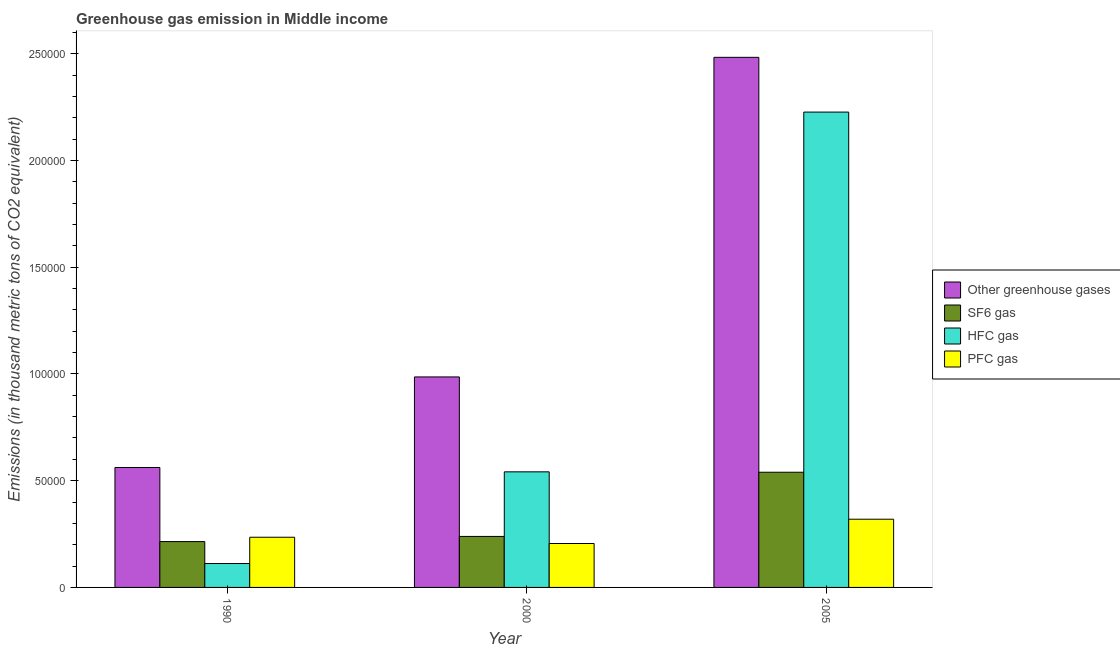How many different coloured bars are there?
Provide a short and direct response. 4. Are the number of bars per tick equal to the number of legend labels?
Your answer should be very brief. Yes. In how many cases, is the number of bars for a given year not equal to the number of legend labels?
Make the answer very short. 0. What is the emission of sf6 gas in 2005?
Ensure brevity in your answer.  5.39e+04. Across all years, what is the maximum emission of greenhouse gases?
Your answer should be very brief. 2.48e+05. Across all years, what is the minimum emission of hfc gas?
Keep it short and to the point. 1.12e+04. What is the total emission of hfc gas in the graph?
Provide a short and direct response. 2.88e+05. What is the difference between the emission of sf6 gas in 1990 and that in 2000?
Your answer should be compact. -2413.4. What is the difference between the emission of greenhouse gases in 1990 and the emission of hfc gas in 2000?
Your answer should be very brief. -4.24e+04. What is the average emission of greenhouse gases per year?
Give a very brief answer. 1.34e+05. What is the ratio of the emission of hfc gas in 1990 to that in 2005?
Your answer should be compact. 0.05. Is the difference between the emission of sf6 gas in 1990 and 2000 greater than the difference between the emission of hfc gas in 1990 and 2000?
Make the answer very short. No. What is the difference between the highest and the second highest emission of greenhouse gases?
Offer a very short reply. 1.50e+05. What is the difference between the highest and the lowest emission of sf6 gas?
Make the answer very short. 3.25e+04. Is it the case that in every year, the sum of the emission of pfc gas and emission of hfc gas is greater than the sum of emission of sf6 gas and emission of greenhouse gases?
Offer a terse response. No. What does the 3rd bar from the left in 2000 represents?
Your response must be concise. HFC gas. What does the 1st bar from the right in 2005 represents?
Your response must be concise. PFC gas. How many bars are there?
Your answer should be compact. 12. How many years are there in the graph?
Provide a succinct answer. 3. Does the graph contain any zero values?
Offer a terse response. No. Does the graph contain grids?
Provide a short and direct response. No. How many legend labels are there?
Make the answer very short. 4. What is the title of the graph?
Provide a short and direct response. Greenhouse gas emission in Middle income. Does "Custom duties" appear as one of the legend labels in the graph?
Your response must be concise. No. What is the label or title of the Y-axis?
Provide a succinct answer. Emissions (in thousand metric tons of CO2 equivalent). What is the Emissions (in thousand metric tons of CO2 equivalent) of Other greenhouse gases in 1990?
Provide a short and direct response. 5.62e+04. What is the Emissions (in thousand metric tons of CO2 equivalent) in SF6 gas in 1990?
Offer a terse response. 2.15e+04. What is the Emissions (in thousand metric tons of CO2 equivalent) of HFC gas in 1990?
Your answer should be very brief. 1.12e+04. What is the Emissions (in thousand metric tons of CO2 equivalent) of PFC gas in 1990?
Ensure brevity in your answer.  2.35e+04. What is the Emissions (in thousand metric tons of CO2 equivalent) in Other greenhouse gases in 2000?
Your answer should be very brief. 9.86e+04. What is the Emissions (in thousand metric tons of CO2 equivalent) of SF6 gas in 2000?
Provide a short and direct response. 2.39e+04. What is the Emissions (in thousand metric tons of CO2 equivalent) of HFC gas in 2000?
Make the answer very short. 5.41e+04. What is the Emissions (in thousand metric tons of CO2 equivalent) in PFC gas in 2000?
Your answer should be compact. 2.06e+04. What is the Emissions (in thousand metric tons of CO2 equivalent) of Other greenhouse gases in 2005?
Provide a short and direct response. 2.48e+05. What is the Emissions (in thousand metric tons of CO2 equivalent) in SF6 gas in 2005?
Ensure brevity in your answer.  5.39e+04. What is the Emissions (in thousand metric tons of CO2 equivalent) of HFC gas in 2005?
Offer a terse response. 2.23e+05. What is the Emissions (in thousand metric tons of CO2 equivalent) of PFC gas in 2005?
Give a very brief answer. 3.20e+04. Across all years, what is the maximum Emissions (in thousand metric tons of CO2 equivalent) in Other greenhouse gases?
Offer a terse response. 2.48e+05. Across all years, what is the maximum Emissions (in thousand metric tons of CO2 equivalent) of SF6 gas?
Provide a succinct answer. 5.39e+04. Across all years, what is the maximum Emissions (in thousand metric tons of CO2 equivalent) in HFC gas?
Your answer should be compact. 2.23e+05. Across all years, what is the maximum Emissions (in thousand metric tons of CO2 equivalent) in PFC gas?
Offer a terse response. 3.20e+04. Across all years, what is the minimum Emissions (in thousand metric tons of CO2 equivalent) of Other greenhouse gases?
Ensure brevity in your answer.  5.62e+04. Across all years, what is the minimum Emissions (in thousand metric tons of CO2 equivalent) in SF6 gas?
Provide a short and direct response. 2.15e+04. Across all years, what is the minimum Emissions (in thousand metric tons of CO2 equivalent) in HFC gas?
Ensure brevity in your answer.  1.12e+04. Across all years, what is the minimum Emissions (in thousand metric tons of CO2 equivalent) in PFC gas?
Make the answer very short. 2.06e+04. What is the total Emissions (in thousand metric tons of CO2 equivalent) in Other greenhouse gases in the graph?
Ensure brevity in your answer.  4.03e+05. What is the total Emissions (in thousand metric tons of CO2 equivalent) in SF6 gas in the graph?
Ensure brevity in your answer.  9.93e+04. What is the total Emissions (in thousand metric tons of CO2 equivalent) of HFC gas in the graph?
Offer a terse response. 2.88e+05. What is the total Emissions (in thousand metric tons of CO2 equivalent) in PFC gas in the graph?
Keep it short and to the point. 7.60e+04. What is the difference between the Emissions (in thousand metric tons of CO2 equivalent) in Other greenhouse gases in 1990 and that in 2000?
Offer a terse response. -4.24e+04. What is the difference between the Emissions (in thousand metric tons of CO2 equivalent) in SF6 gas in 1990 and that in 2000?
Provide a short and direct response. -2413.4. What is the difference between the Emissions (in thousand metric tons of CO2 equivalent) in HFC gas in 1990 and that in 2000?
Provide a short and direct response. -4.29e+04. What is the difference between the Emissions (in thousand metric tons of CO2 equivalent) of PFC gas in 1990 and that in 2000?
Your answer should be very brief. 2931.5. What is the difference between the Emissions (in thousand metric tons of CO2 equivalent) of Other greenhouse gases in 1990 and that in 2005?
Offer a terse response. -1.92e+05. What is the difference between the Emissions (in thousand metric tons of CO2 equivalent) in SF6 gas in 1990 and that in 2005?
Give a very brief answer. -3.25e+04. What is the difference between the Emissions (in thousand metric tons of CO2 equivalent) in HFC gas in 1990 and that in 2005?
Provide a succinct answer. -2.11e+05. What is the difference between the Emissions (in thousand metric tons of CO2 equivalent) of PFC gas in 1990 and that in 2005?
Offer a terse response. -8451.4. What is the difference between the Emissions (in thousand metric tons of CO2 equivalent) of Other greenhouse gases in 2000 and that in 2005?
Offer a terse response. -1.50e+05. What is the difference between the Emissions (in thousand metric tons of CO2 equivalent) of SF6 gas in 2000 and that in 2005?
Offer a terse response. -3.01e+04. What is the difference between the Emissions (in thousand metric tons of CO2 equivalent) in HFC gas in 2000 and that in 2005?
Your response must be concise. -1.68e+05. What is the difference between the Emissions (in thousand metric tons of CO2 equivalent) of PFC gas in 2000 and that in 2005?
Keep it short and to the point. -1.14e+04. What is the difference between the Emissions (in thousand metric tons of CO2 equivalent) in Other greenhouse gases in 1990 and the Emissions (in thousand metric tons of CO2 equivalent) in SF6 gas in 2000?
Provide a short and direct response. 3.23e+04. What is the difference between the Emissions (in thousand metric tons of CO2 equivalent) of Other greenhouse gases in 1990 and the Emissions (in thousand metric tons of CO2 equivalent) of HFC gas in 2000?
Give a very brief answer. 2035.7. What is the difference between the Emissions (in thousand metric tons of CO2 equivalent) in Other greenhouse gases in 1990 and the Emissions (in thousand metric tons of CO2 equivalent) in PFC gas in 2000?
Offer a terse response. 3.56e+04. What is the difference between the Emissions (in thousand metric tons of CO2 equivalent) of SF6 gas in 1990 and the Emissions (in thousand metric tons of CO2 equivalent) of HFC gas in 2000?
Your response must be concise. -3.27e+04. What is the difference between the Emissions (in thousand metric tons of CO2 equivalent) in SF6 gas in 1990 and the Emissions (in thousand metric tons of CO2 equivalent) in PFC gas in 2000?
Keep it short and to the point. 902.9. What is the difference between the Emissions (in thousand metric tons of CO2 equivalent) in HFC gas in 1990 and the Emissions (in thousand metric tons of CO2 equivalent) in PFC gas in 2000?
Ensure brevity in your answer.  -9371.2. What is the difference between the Emissions (in thousand metric tons of CO2 equivalent) of Other greenhouse gases in 1990 and the Emissions (in thousand metric tons of CO2 equivalent) of SF6 gas in 2005?
Offer a very short reply. 2227.28. What is the difference between the Emissions (in thousand metric tons of CO2 equivalent) of Other greenhouse gases in 1990 and the Emissions (in thousand metric tons of CO2 equivalent) of HFC gas in 2005?
Your answer should be very brief. -1.66e+05. What is the difference between the Emissions (in thousand metric tons of CO2 equivalent) in Other greenhouse gases in 1990 and the Emissions (in thousand metric tons of CO2 equivalent) in PFC gas in 2005?
Ensure brevity in your answer.  2.42e+04. What is the difference between the Emissions (in thousand metric tons of CO2 equivalent) of SF6 gas in 1990 and the Emissions (in thousand metric tons of CO2 equivalent) of HFC gas in 2005?
Your answer should be very brief. -2.01e+05. What is the difference between the Emissions (in thousand metric tons of CO2 equivalent) of SF6 gas in 1990 and the Emissions (in thousand metric tons of CO2 equivalent) of PFC gas in 2005?
Provide a short and direct response. -1.05e+04. What is the difference between the Emissions (in thousand metric tons of CO2 equivalent) of HFC gas in 1990 and the Emissions (in thousand metric tons of CO2 equivalent) of PFC gas in 2005?
Ensure brevity in your answer.  -2.08e+04. What is the difference between the Emissions (in thousand metric tons of CO2 equivalent) in Other greenhouse gases in 2000 and the Emissions (in thousand metric tons of CO2 equivalent) in SF6 gas in 2005?
Make the answer very short. 4.46e+04. What is the difference between the Emissions (in thousand metric tons of CO2 equivalent) of Other greenhouse gases in 2000 and the Emissions (in thousand metric tons of CO2 equivalent) of HFC gas in 2005?
Give a very brief answer. -1.24e+05. What is the difference between the Emissions (in thousand metric tons of CO2 equivalent) of Other greenhouse gases in 2000 and the Emissions (in thousand metric tons of CO2 equivalent) of PFC gas in 2005?
Your response must be concise. 6.66e+04. What is the difference between the Emissions (in thousand metric tons of CO2 equivalent) of SF6 gas in 2000 and the Emissions (in thousand metric tons of CO2 equivalent) of HFC gas in 2005?
Offer a very short reply. -1.99e+05. What is the difference between the Emissions (in thousand metric tons of CO2 equivalent) of SF6 gas in 2000 and the Emissions (in thousand metric tons of CO2 equivalent) of PFC gas in 2005?
Offer a terse response. -8066.6. What is the difference between the Emissions (in thousand metric tons of CO2 equivalent) of HFC gas in 2000 and the Emissions (in thousand metric tons of CO2 equivalent) of PFC gas in 2005?
Provide a succinct answer. 2.22e+04. What is the average Emissions (in thousand metric tons of CO2 equivalent) of Other greenhouse gases per year?
Offer a terse response. 1.34e+05. What is the average Emissions (in thousand metric tons of CO2 equivalent) in SF6 gas per year?
Your response must be concise. 3.31e+04. What is the average Emissions (in thousand metric tons of CO2 equivalent) of HFC gas per year?
Your response must be concise. 9.60e+04. What is the average Emissions (in thousand metric tons of CO2 equivalent) of PFC gas per year?
Your answer should be very brief. 2.53e+04. In the year 1990, what is the difference between the Emissions (in thousand metric tons of CO2 equivalent) in Other greenhouse gases and Emissions (in thousand metric tons of CO2 equivalent) in SF6 gas?
Make the answer very short. 3.47e+04. In the year 1990, what is the difference between the Emissions (in thousand metric tons of CO2 equivalent) in Other greenhouse gases and Emissions (in thousand metric tons of CO2 equivalent) in HFC gas?
Provide a succinct answer. 4.50e+04. In the year 1990, what is the difference between the Emissions (in thousand metric tons of CO2 equivalent) of Other greenhouse gases and Emissions (in thousand metric tons of CO2 equivalent) of PFC gas?
Provide a short and direct response. 3.27e+04. In the year 1990, what is the difference between the Emissions (in thousand metric tons of CO2 equivalent) of SF6 gas and Emissions (in thousand metric tons of CO2 equivalent) of HFC gas?
Offer a terse response. 1.03e+04. In the year 1990, what is the difference between the Emissions (in thousand metric tons of CO2 equivalent) in SF6 gas and Emissions (in thousand metric tons of CO2 equivalent) in PFC gas?
Your response must be concise. -2028.6. In the year 1990, what is the difference between the Emissions (in thousand metric tons of CO2 equivalent) in HFC gas and Emissions (in thousand metric tons of CO2 equivalent) in PFC gas?
Your response must be concise. -1.23e+04. In the year 2000, what is the difference between the Emissions (in thousand metric tons of CO2 equivalent) of Other greenhouse gases and Emissions (in thousand metric tons of CO2 equivalent) of SF6 gas?
Your answer should be compact. 7.47e+04. In the year 2000, what is the difference between the Emissions (in thousand metric tons of CO2 equivalent) of Other greenhouse gases and Emissions (in thousand metric tons of CO2 equivalent) of HFC gas?
Offer a very short reply. 4.45e+04. In the year 2000, what is the difference between the Emissions (in thousand metric tons of CO2 equivalent) of Other greenhouse gases and Emissions (in thousand metric tons of CO2 equivalent) of PFC gas?
Ensure brevity in your answer.  7.80e+04. In the year 2000, what is the difference between the Emissions (in thousand metric tons of CO2 equivalent) of SF6 gas and Emissions (in thousand metric tons of CO2 equivalent) of HFC gas?
Offer a terse response. -3.03e+04. In the year 2000, what is the difference between the Emissions (in thousand metric tons of CO2 equivalent) of SF6 gas and Emissions (in thousand metric tons of CO2 equivalent) of PFC gas?
Provide a short and direct response. 3316.3. In the year 2000, what is the difference between the Emissions (in thousand metric tons of CO2 equivalent) in HFC gas and Emissions (in thousand metric tons of CO2 equivalent) in PFC gas?
Ensure brevity in your answer.  3.36e+04. In the year 2005, what is the difference between the Emissions (in thousand metric tons of CO2 equivalent) of Other greenhouse gases and Emissions (in thousand metric tons of CO2 equivalent) of SF6 gas?
Your answer should be very brief. 1.94e+05. In the year 2005, what is the difference between the Emissions (in thousand metric tons of CO2 equivalent) of Other greenhouse gases and Emissions (in thousand metric tons of CO2 equivalent) of HFC gas?
Provide a short and direct response. 2.56e+04. In the year 2005, what is the difference between the Emissions (in thousand metric tons of CO2 equivalent) of Other greenhouse gases and Emissions (in thousand metric tons of CO2 equivalent) of PFC gas?
Offer a very short reply. 2.16e+05. In the year 2005, what is the difference between the Emissions (in thousand metric tons of CO2 equivalent) in SF6 gas and Emissions (in thousand metric tons of CO2 equivalent) in HFC gas?
Your answer should be very brief. -1.69e+05. In the year 2005, what is the difference between the Emissions (in thousand metric tons of CO2 equivalent) in SF6 gas and Emissions (in thousand metric tons of CO2 equivalent) in PFC gas?
Provide a succinct answer. 2.20e+04. In the year 2005, what is the difference between the Emissions (in thousand metric tons of CO2 equivalent) of HFC gas and Emissions (in thousand metric tons of CO2 equivalent) of PFC gas?
Provide a short and direct response. 1.91e+05. What is the ratio of the Emissions (in thousand metric tons of CO2 equivalent) of Other greenhouse gases in 1990 to that in 2000?
Your answer should be compact. 0.57. What is the ratio of the Emissions (in thousand metric tons of CO2 equivalent) in SF6 gas in 1990 to that in 2000?
Make the answer very short. 0.9. What is the ratio of the Emissions (in thousand metric tons of CO2 equivalent) of HFC gas in 1990 to that in 2000?
Your answer should be very brief. 0.21. What is the ratio of the Emissions (in thousand metric tons of CO2 equivalent) in PFC gas in 1990 to that in 2000?
Your answer should be compact. 1.14. What is the ratio of the Emissions (in thousand metric tons of CO2 equivalent) of Other greenhouse gases in 1990 to that in 2005?
Offer a terse response. 0.23. What is the ratio of the Emissions (in thousand metric tons of CO2 equivalent) in SF6 gas in 1990 to that in 2005?
Provide a short and direct response. 0.4. What is the ratio of the Emissions (in thousand metric tons of CO2 equivalent) in HFC gas in 1990 to that in 2005?
Provide a short and direct response. 0.05. What is the ratio of the Emissions (in thousand metric tons of CO2 equivalent) of PFC gas in 1990 to that in 2005?
Provide a short and direct response. 0.74. What is the ratio of the Emissions (in thousand metric tons of CO2 equivalent) in Other greenhouse gases in 2000 to that in 2005?
Ensure brevity in your answer.  0.4. What is the ratio of the Emissions (in thousand metric tons of CO2 equivalent) in SF6 gas in 2000 to that in 2005?
Give a very brief answer. 0.44. What is the ratio of the Emissions (in thousand metric tons of CO2 equivalent) in HFC gas in 2000 to that in 2005?
Ensure brevity in your answer.  0.24. What is the ratio of the Emissions (in thousand metric tons of CO2 equivalent) in PFC gas in 2000 to that in 2005?
Provide a short and direct response. 0.64. What is the difference between the highest and the second highest Emissions (in thousand metric tons of CO2 equivalent) of Other greenhouse gases?
Your response must be concise. 1.50e+05. What is the difference between the highest and the second highest Emissions (in thousand metric tons of CO2 equivalent) of SF6 gas?
Your answer should be very brief. 3.01e+04. What is the difference between the highest and the second highest Emissions (in thousand metric tons of CO2 equivalent) of HFC gas?
Your answer should be compact. 1.68e+05. What is the difference between the highest and the second highest Emissions (in thousand metric tons of CO2 equivalent) of PFC gas?
Provide a short and direct response. 8451.4. What is the difference between the highest and the lowest Emissions (in thousand metric tons of CO2 equivalent) in Other greenhouse gases?
Keep it short and to the point. 1.92e+05. What is the difference between the highest and the lowest Emissions (in thousand metric tons of CO2 equivalent) of SF6 gas?
Your response must be concise. 3.25e+04. What is the difference between the highest and the lowest Emissions (in thousand metric tons of CO2 equivalent) of HFC gas?
Keep it short and to the point. 2.11e+05. What is the difference between the highest and the lowest Emissions (in thousand metric tons of CO2 equivalent) in PFC gas?
Provide a short and direct response. 1.14e+04. 